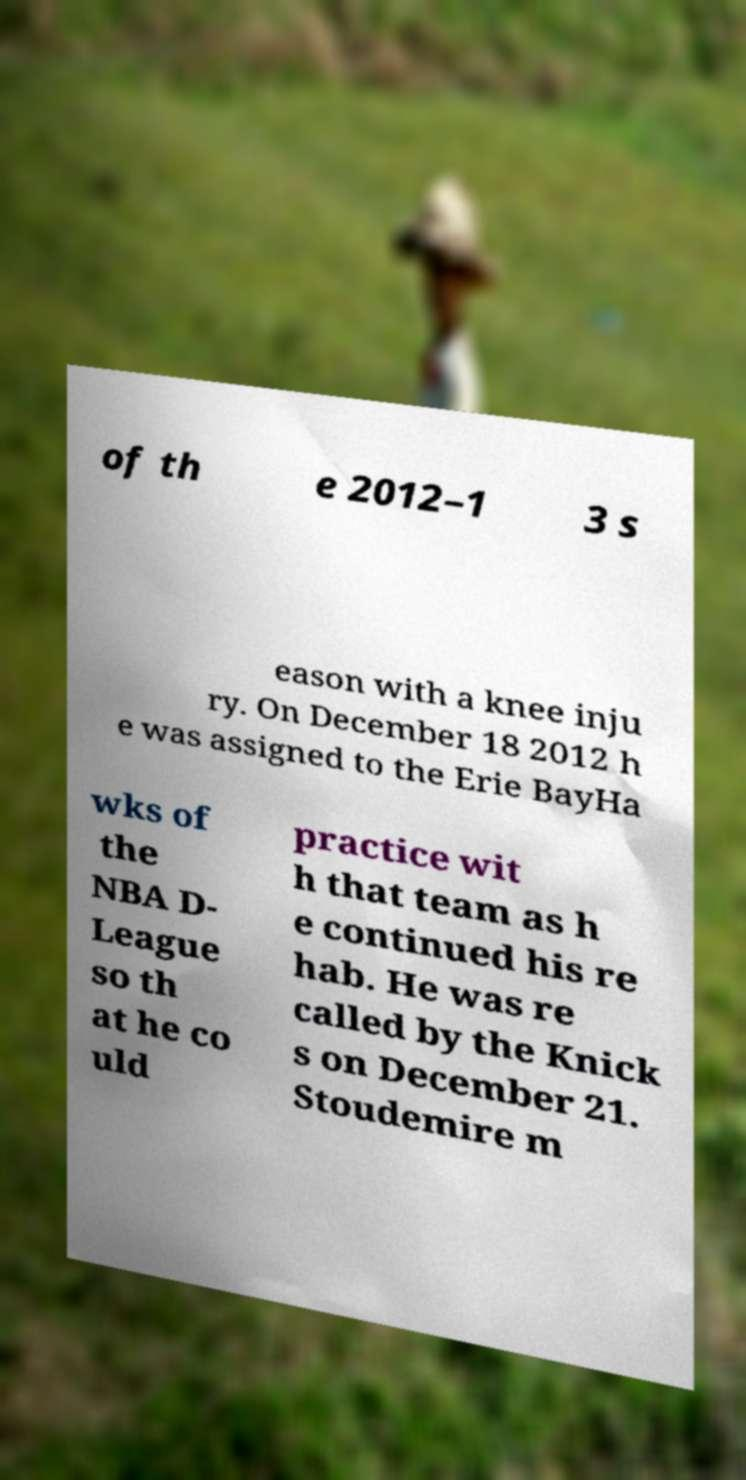For documentation purposes, I need the text within this image transcribed. Could you provide that? of th e 2012–1 3 s eason with a knee inju ry. On December 18 2012 h e was assigned to the Erie BayHa wks of the NBA D- League so th at he co uld practice wit h that team as h e continued his re hab. He was re called by the Knick s on December 21. Stoudemire m 